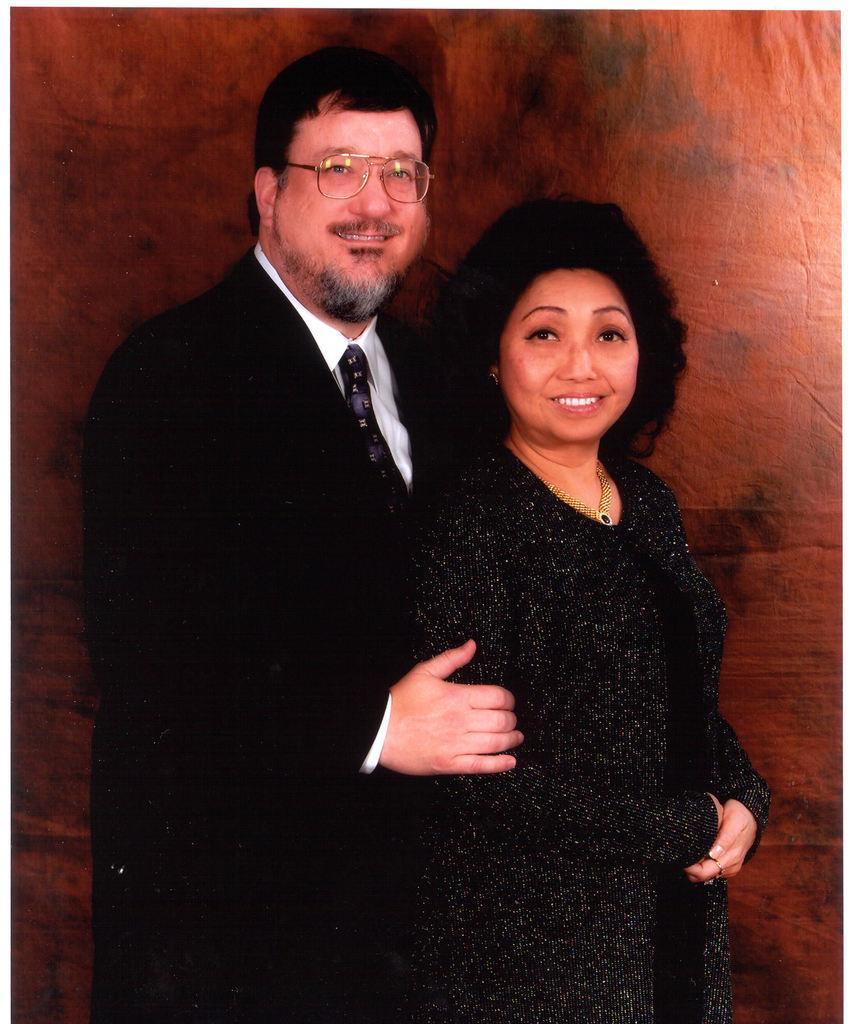Describe this image in one or two sentences. There is a person in black color suit, smiling, standing and holding a woman who is in black color dress, smiling and standing. And the background is brown in color. 